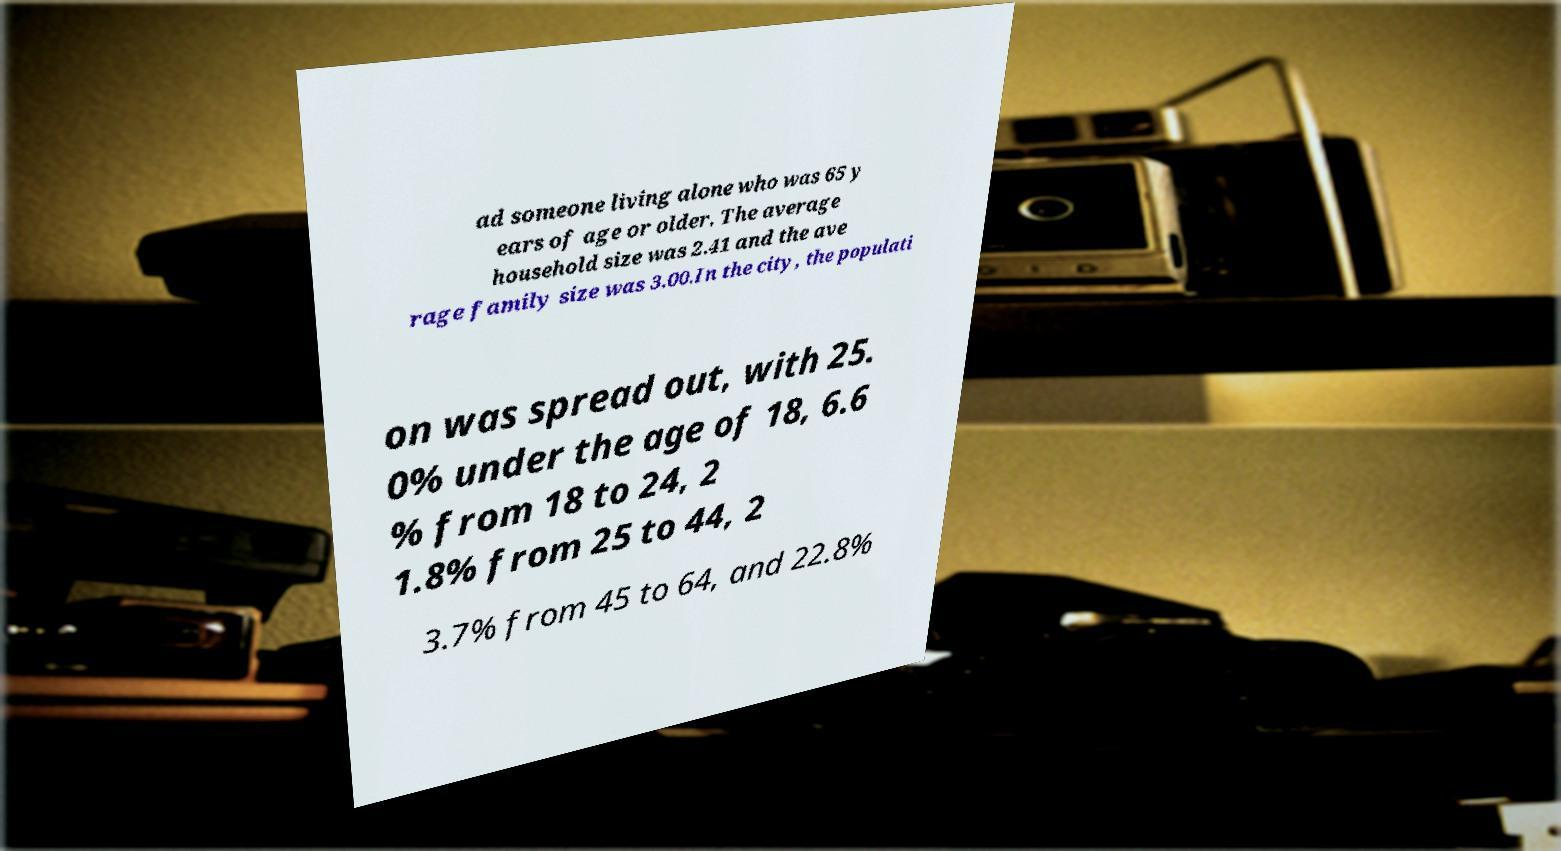I need the written content from this picture converted into text. Can you do that? ad someone living alone who was 65 y ears of age or older. The average household size was 2.41 and the ave rage family size was 3.00.In the city, the populati on was spread out, with 25. 0% under the age of 18, 6.6 % from 18 to 24, 2 1.8% from 25 to 44, 2 3.7% from 45 to 64, and 22.8% 